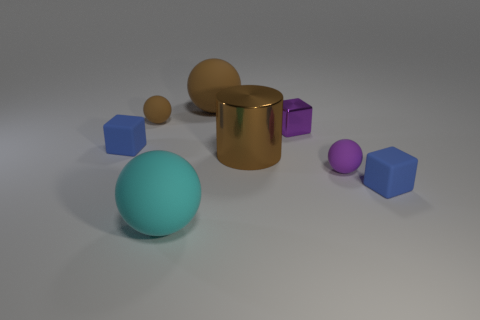Add 1 tiny blue shiny balls. How many objects exist? 9 Subtract all cylinders. How many objects are left? 7 Subtract all gray metal objects. Subtract all big cyan rubber spheres. How many objects are left? 7 Add 7 purple cubes. How many purple cubes are left? 8 Add 4 cyan metallic cylinders. How many cyan metallic cylinders exist? 4 Subtract 0 yellow blocks. How many objects are left? 8 